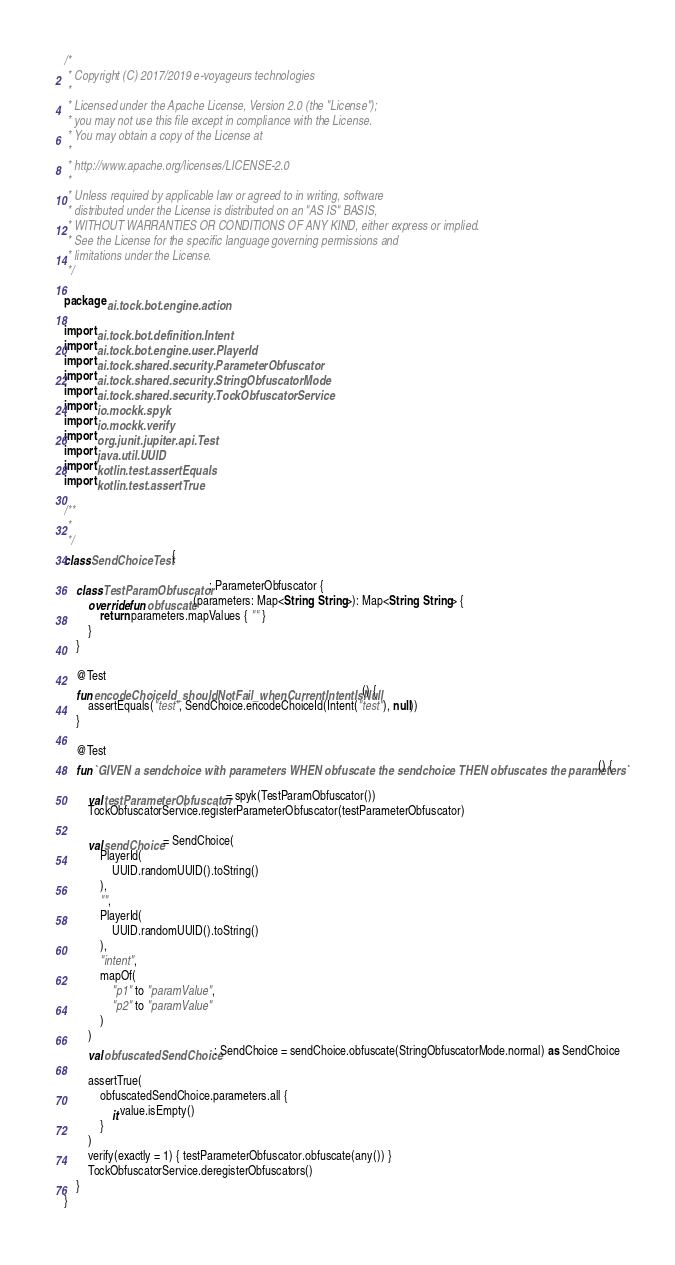Convert code to text. <code><loc_0><loc_0><loc_500><loc_500><_Kotlin_>/*
 * Copyright (C) 2017/2019 e-voyageurs technologies
 *
 * Licensed under the Apache License, Version 2.0 (the "License");
 * you may not use this file except in compliance with the License.
 * You may obtain a copy of the License at
 *
 * http://www.apache.org/licenses/LICENSE-2.0
 *
 * Unless required by applicable law or agreed to in writing, software
 * distributed under the License is distributed on an "AS IS" BASIS,
 * WITHOUT WARRANTIES OR CONDITIONS OF ANY KIND, either express or implied.
 * See the License for the specific language governing permissions and
 * limitations under the License.
 */

package ai.tock.bot.engine.action

import ai.tock.bot.definition.Intent
import ai.tock.bot.engine.user.PlayerId
import ai.tock.shared.security.ParameterObfuscator
import ai.tock.shared.security.StringObfuscatorMode
import ai.tock.shared.security.TockObfuscatorService
import io.mockk.spyk
import io.mockk.verify
import org.junit.jupiter.api.Test
import java.util.UUID
import kotlin.test.assertEquals
import kotlin.test.assertTrue

/**
 *
 */
class SendChoiceTest {

    class TestParamObfuscator : ParameterObfuscator {
        override fun obfuscate(parameters: Map<String, String>): Map<String, String> {
            return parameters.mapValues { "" }
        }
    }

    @Test
    fun encodeChoiceId_shouldNotFail_whenCurrentIntentIsNull() {
        assertEquals("test", SendChoice.encodeChoiceId(Intent("test"), null))
    }

    @Test
    fun `GIVEN a sendchoice with parameters WHEN obfuscate the sendchoice THEN obfuscates the parameters`() {

        val testParameterObfuscator = spyk(TestParamObfuscator())
        TockObfuscatorService.registerParameterObfuscator(testParameterObfuscator)

        val sendChoice = SendChoice(
            PlayerId(
                UUID.randomUUID().toString()
            ),
            "",
            PlayerId(
                UUID.randomUUID().toString()
            ),
            "intent",
            mapOf(
                "p1" to "paramValue",
                "p2" to "paramValue"
            )
        )
        val obfuscatedSendChoice: SendChoice = sendChoice.obfuscate(StringObfuscatorMode.normal) as SendChoice

        assertTrue(
            obfuscatedSendChoice.parameters.all {
                it.value.isEmpty()
            }
        )
        verify(exactly = 1) { testParameterObfuscator.obfuscate(any()) }
        TockObfuscatorService.deregisterObfuscators()
    }
}</code> 